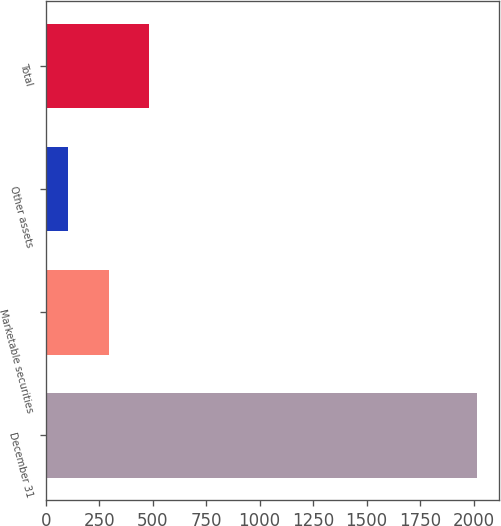<chart> <loc_0><loc_0><loc_500><loc_500><bar_chart><fcel>December 31<fcel>Marketable securities<fcel>Other assets<fcel>Total<nl><fcel>2016<fcel>293.4<fcel>102<fcel>484.8<nl></chart> 